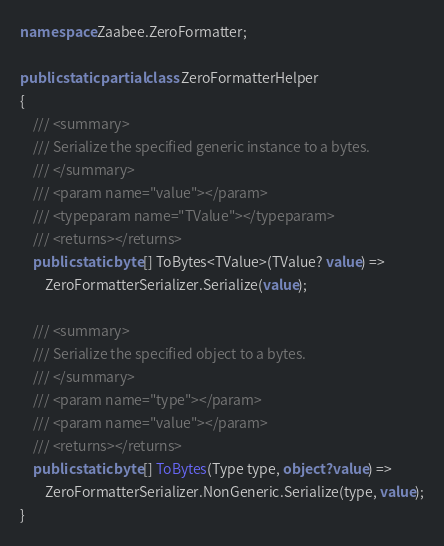Convert code to text. <code><loc_0><loc_0><loc_500><loc_500><_C#_>namespace Zaabee.ZeroFormatter;

public static partial class ZeroFormatterHelper
{
    /// <summary>
    /// Serialize the specified generic instance to a bytes.
    /// </summary>
    /// <param name="value"></param>
    /// <typeparam name="TValue"></typeparam>
    /// <returns></returns>
    public static byte[] ToBytes<TValue>(TValue? value) =>
        ZeroFormatterSerializer.Serialize(value);

    /// <summary>
    /// Serialize the specified object to a bytes.
    /// </summary>
    /// <param name="type"></param>
    /// <param name="value"></param>
    /// <returns></returns>
    public static byte[] ToBytes(Type type, object? value) =>
        ZeroFormatterSerializer.NonGeneric.Serialize(type, value);
}</code> 